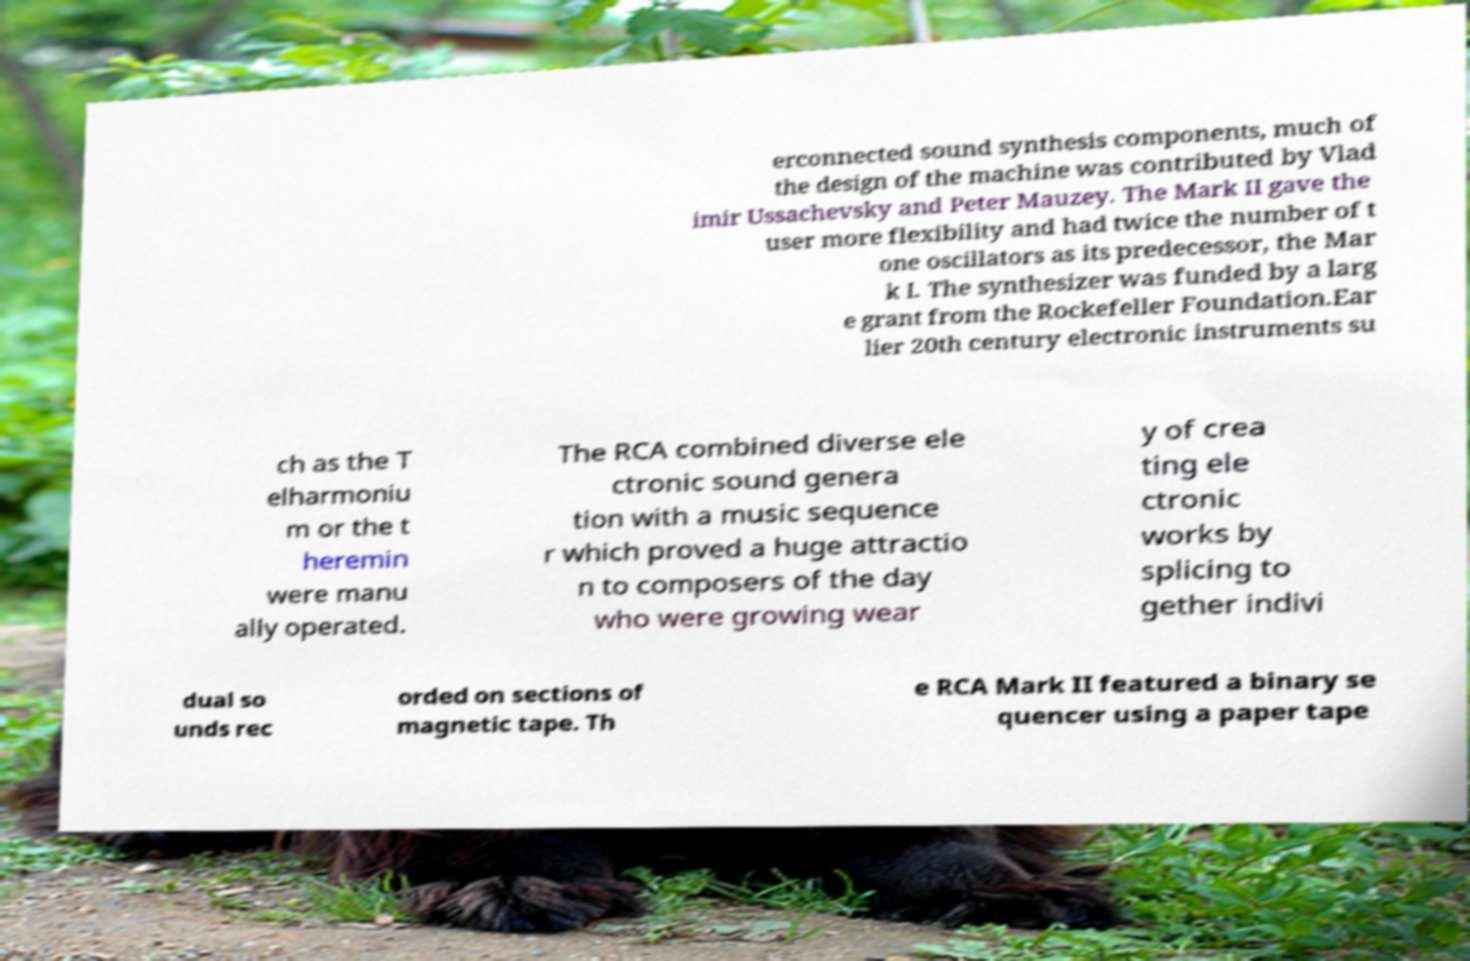Can you read and provide the text displayed in the image?This photo seems to have some interesting text. Can you extract and type it out for me? erconnected sound synthesis components, much of the design of the machine was contributed by Vlad imir Ussachevsky and Peter Mauzey. The Mark II gave the user more flexibility and had twice the number of t one oscillators as its predecessor, the Mar k I. The synthesizer was funded by a larg e grant from the Rockefeller Foundation.Ear lier 20th century electronic instruments su ch as the T elharmoniu m or the t heremin were manu ally operated. The RCA combined diverse ele ctronic sound genera tion with a music sequence r which proved a huge attractio n to composers of the day who were growing wear y of crea ting ele ctronic works by splicing to gether indivi dual so unds rec orded on sections of magnetic tape. Th e RCA Mark II featured a binary se quencer using a paper tape 